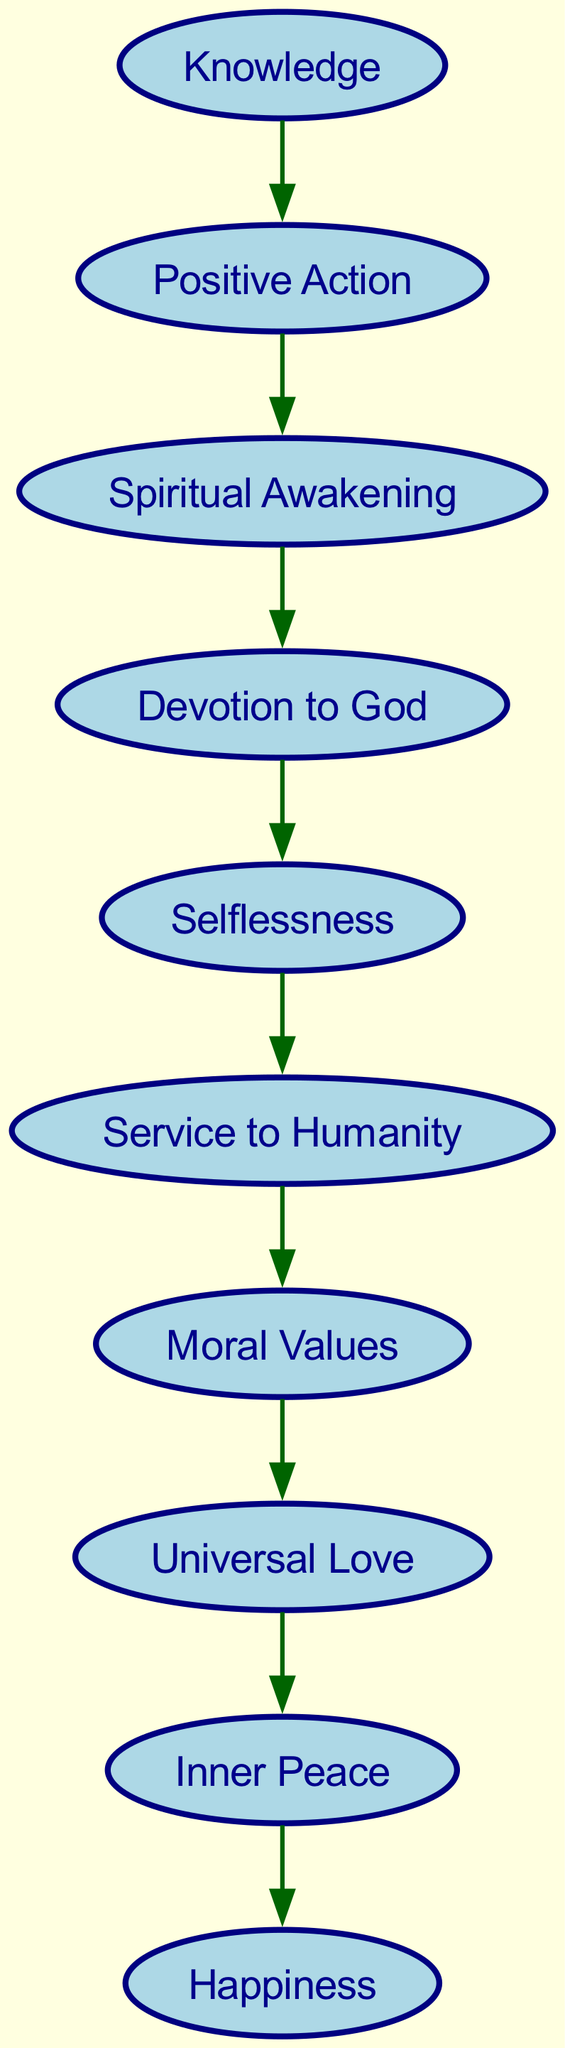What is the starting point of the hierarchy? The diagram shows that "Spiritual Awakening" is the starting point, as it has no incoming edges and connects to "Devotion to God."
Answer: Spiritual Awakening Which value is directly connected to "Devotion to God"? "Selflessness" follows "Devotion to God" in the hierarchy as indicated by the directed edge from "Devotion to God" to "Selflessness."
Answer: Selflessness How many nodes are in the diagram? There are ten nodes present in the diagram, as listed in the "nodes" data.
Answer: 10 Which value leads to "Inner Peace"? The value "Universal Love" is the direct predecessor of "Inner Peace" in the hierarchy, with a directed edge from "Universal Love" to "Inner Peace."
Answer: Universal Love What are the last two values in the hierarchy? The last two values are "Happiness," which is reached after "Inner Peace," and "Knowledge," leading to "Positive Action," which starts a new cycle back to "Spiritual Awakening."
Answer: Happiness, Knowledge What is the relationship between "Knowledge" and "Spiritual Awakening"? "Knowledge" leads to "Positive Action," which then directs back to "Spiritual Awakening," forming a cycle and indicating a strategic importance in the hierarchy.
Answer: Positive Action Which value is linked to "Service to Humanity"? "Moral Values" is the value linked to "Service to Humanity," as there is a directed edge from "Service to Humanity" to "Moral Values."
Answer: Moral Values How many edges are there in the diagram? Counting the edges, there are nine distinct connections between the nodes that represent relationships in the hierarchy.
Answer: 9 What value follows "Selflessness" in the hierarchy? "Service to Humanity" directly follows "Selflessness," as seen in the directed edge between them.
Answer: Service to Humanity 